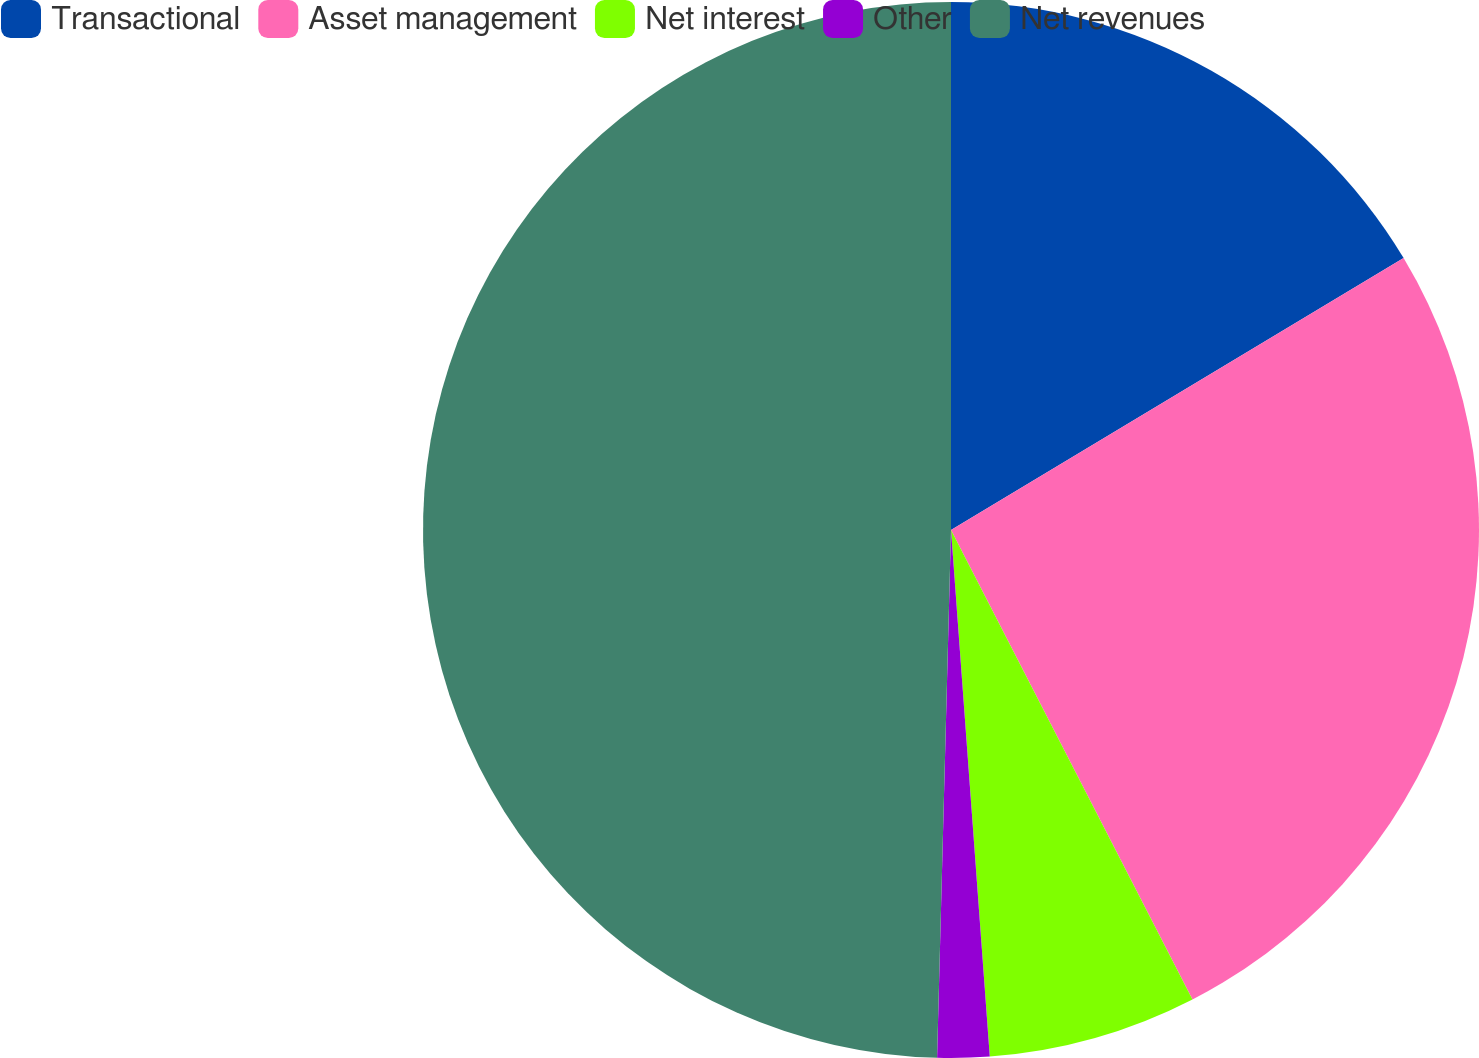<chart> <loc_0><loc_0><loc_500><loc_500><pie_chart><fcel>Transactional<fcel>Asset management<fcel>Net interest<fcel>Other<fcel>Net revenues<nl><fcel>16.39%<fcel>26.05%<fcel>6.39%<fcel>1.59%<fcel>49.58%<nl></chart> 